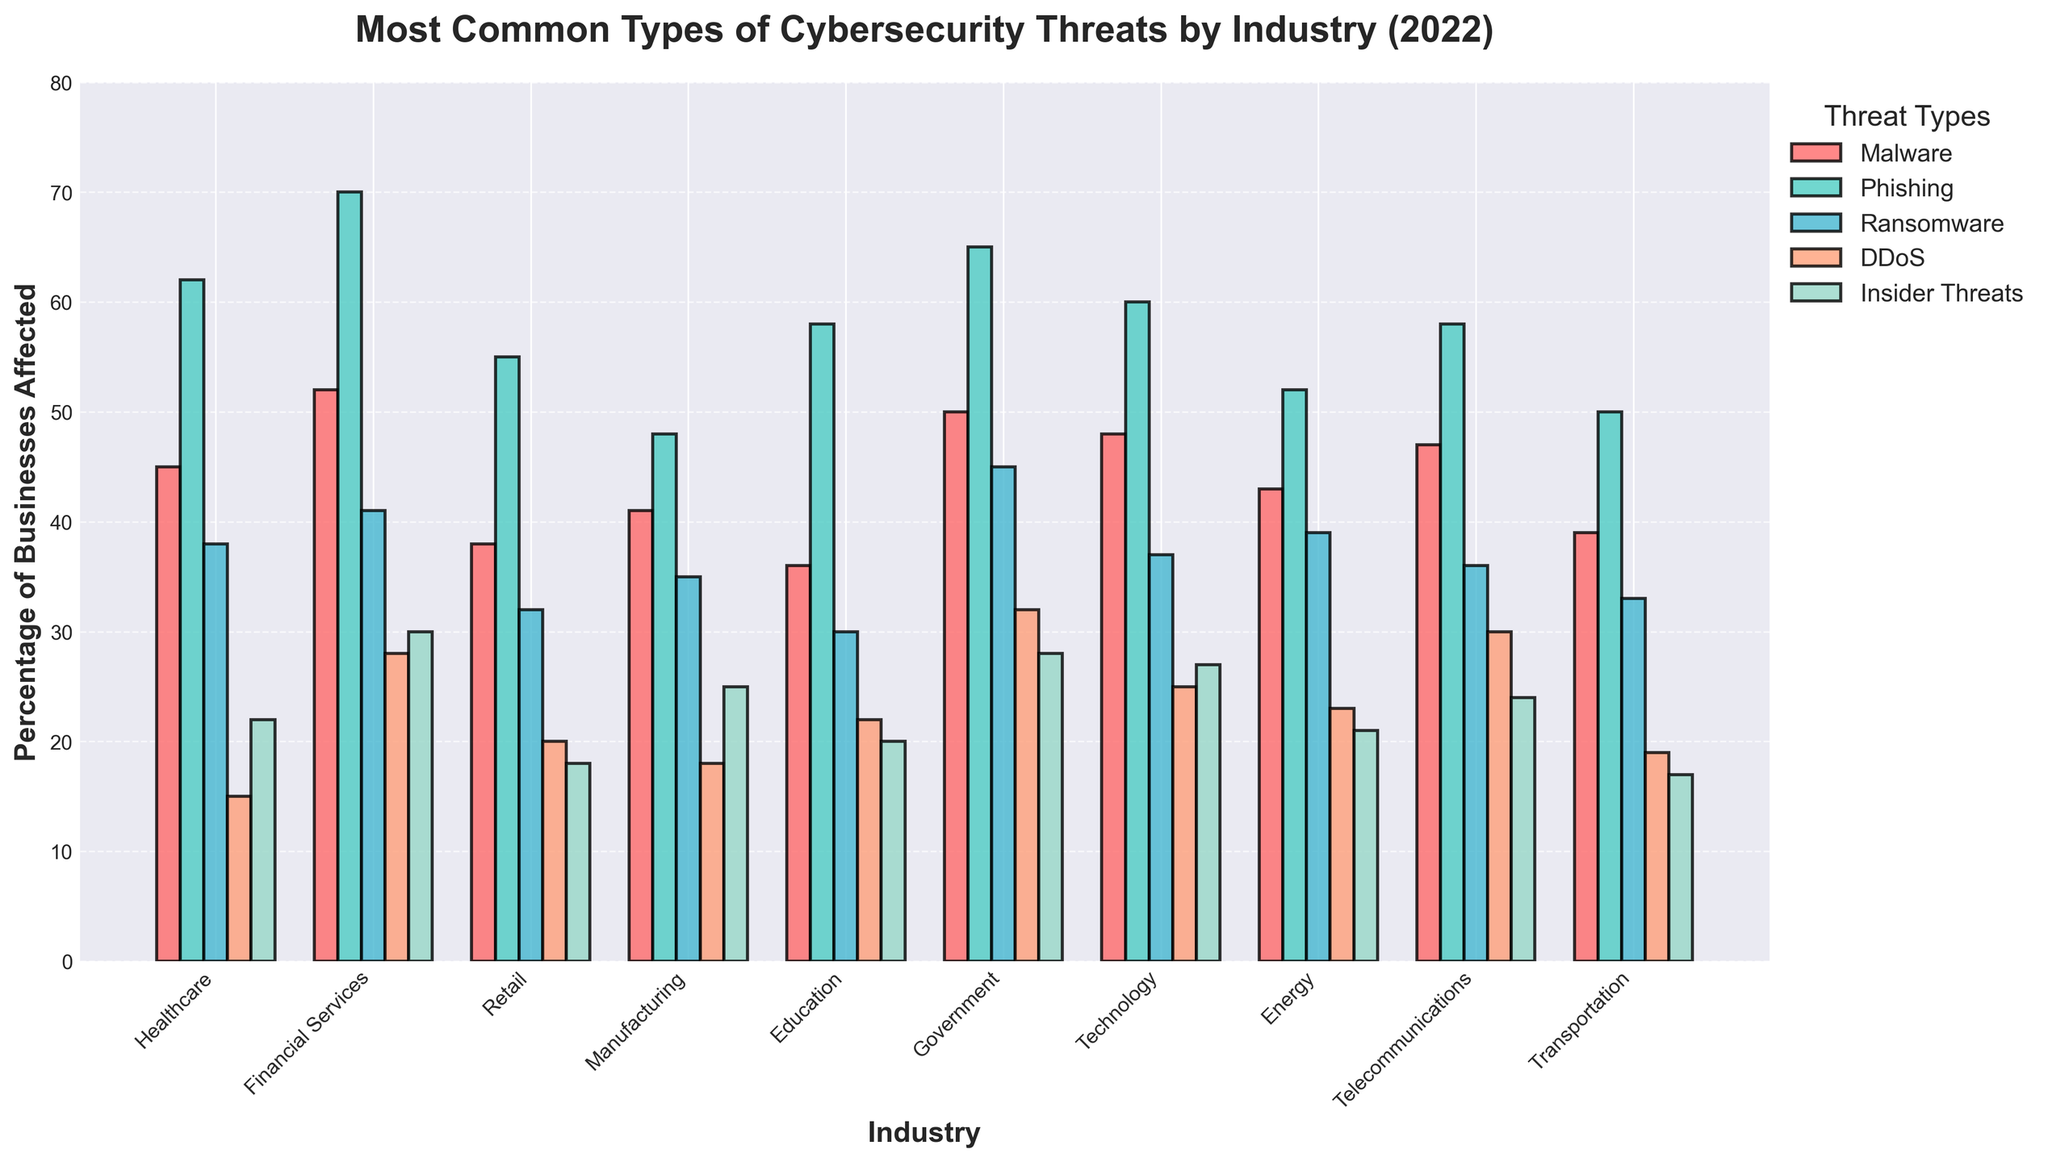Which industry reported the highest percentage of businesses affected by Phishing? The industry with the highest bar corresponding to Phishing (green) will report the highest percentage. From the chart, the Financial Services industry has the highest green bar, indicating the highest percentage of businesses affected by Phishing.
Answer: Financial Services Which types of cybersecurity threats affected Healthcare more than Retail? Compare the heights of the bars for each cybersecurity threat between Healthcare and Retail. Healthcare has higher bars for Malware (red), Phishing (green), and Ransomware (blue) than Retail.
Answer: Malware, Phishing, Ransomware What is the average percentage of businesses affected by Insider Threats across all industries? Sum the percentages of businesses affected by Insider Threats across all industries and divide by the number of industries (10). (22 + 30 + 18 + 25 + 20 + 28 + 27 + 21 + 24 + 17) = 232. The average is 232 / 10 = 23.2
Answer: 23.2 Which industry has a higher percentage of businesses affected by DDoS, Technology or Telecommunications? Compare the heights of the DDoS bars (orange) for Technology and Telecommunications. The bar for Telecommunications is higher than the bar for Technology.
Answer: Telecommunications What is the difference in the percentage of businesses affected by Ransomware between Government and Education sectors? Subtract the percentage of businesses affected by Ransomware in the Education sector from that in the Government sector. Government has 45%, and Education has 30%, so the difference is 45% - 30% = 15%.
Answer: 15% Identify the industry with the lowest percentage of businesses affected by Malware. Look at the height of the red bars representing Malware across all industries and identify the shortest one. The Education industry has the shortest red bar for Malware.
Answer: Education Which threat type affects the Energy industry more than Transportation but less than Financial Services? Compare the heights of bars for each threat type in the Energy, Transportation, and Financial Services industries. For Ransomware (blue), Energy's bar is taller than Transportation's but shorter than Financial Services'.
Answer: Ransomware How many industries report over 50% of businesses affected by Phishing? Count the number of industries where the green bar, representing Phishing, is above the 50% mark on the y-axis. The industries are Healthcare, Financial Services, Education, Government, Technology, and Telecommunications. This gives 6 industries.
Answer: 6 For the Manufacturing industry, which threat is the second most reported? Within the Manufacturing industry, check the height of bars for all threats and identify the second tallest. Phishing (green) is the most reported, and the second most reported is Insider Threats (teal).
Answer: Insider Threats Is the percentage of businesses affected by DDoS greater in the Financial Services industry or the Government industry? Compare the heights of the DDoS bars (orange) for Financial Services and Government industries. The bar for the Government industry is taller than the bar for Financial Services.
Answer: Government 